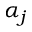Convert formula to latex. <formula><loc_0><loc_0><loc_500><loc_500>\alpha _ { j }</formula> 